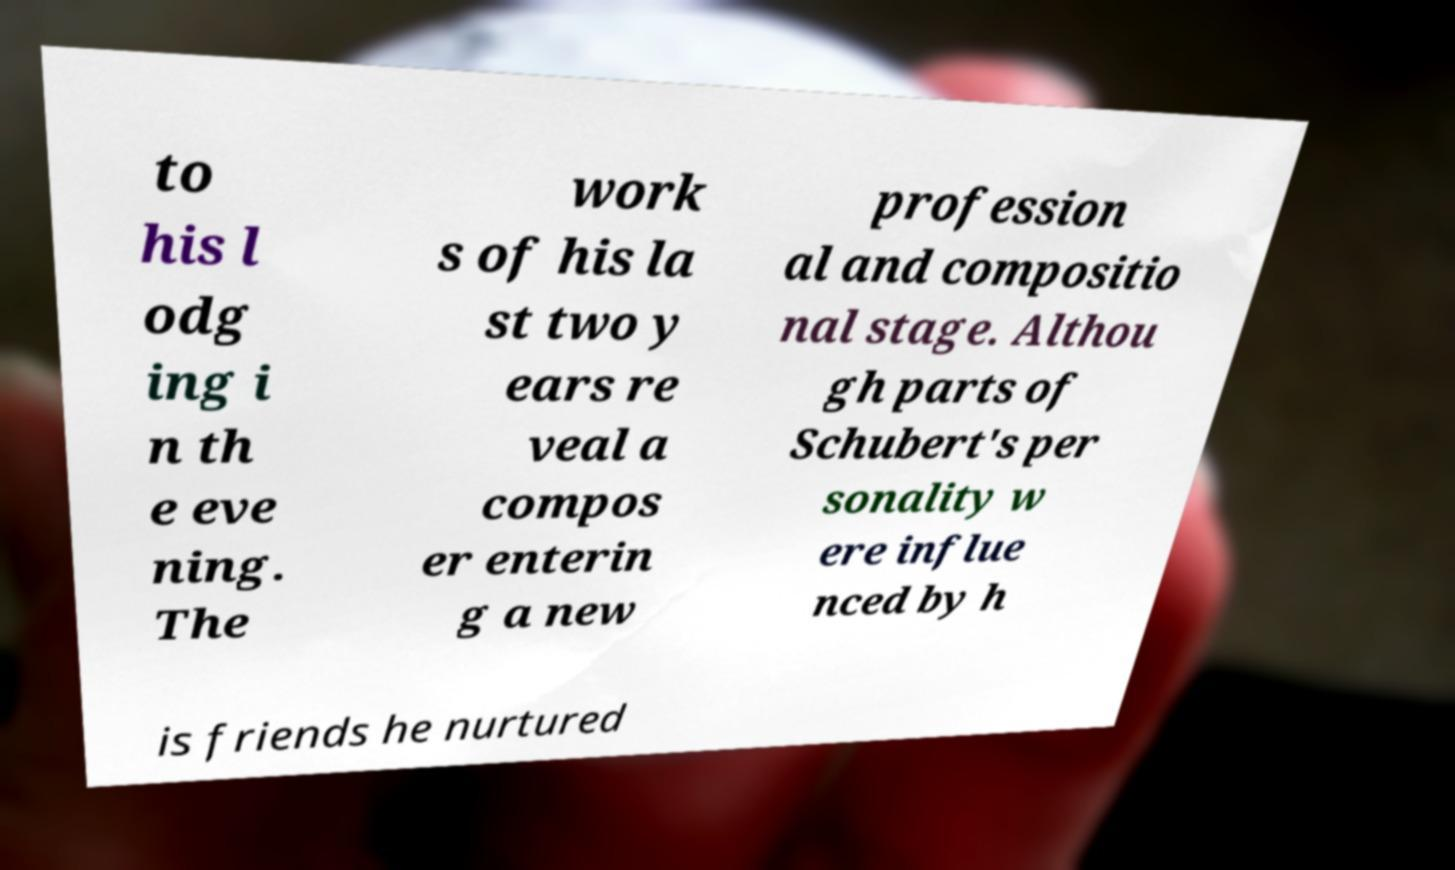What messages or text are displayed in this image? I need them in a readable, typed format. to his l odg ing i n th e eve ning. The work s of his la st two y ears re veal a compos er enterin g a new profession al and compositio nal stage. Althou gh parts of Schubert's per sonality w ere influe nced by h is friends he nurtured 